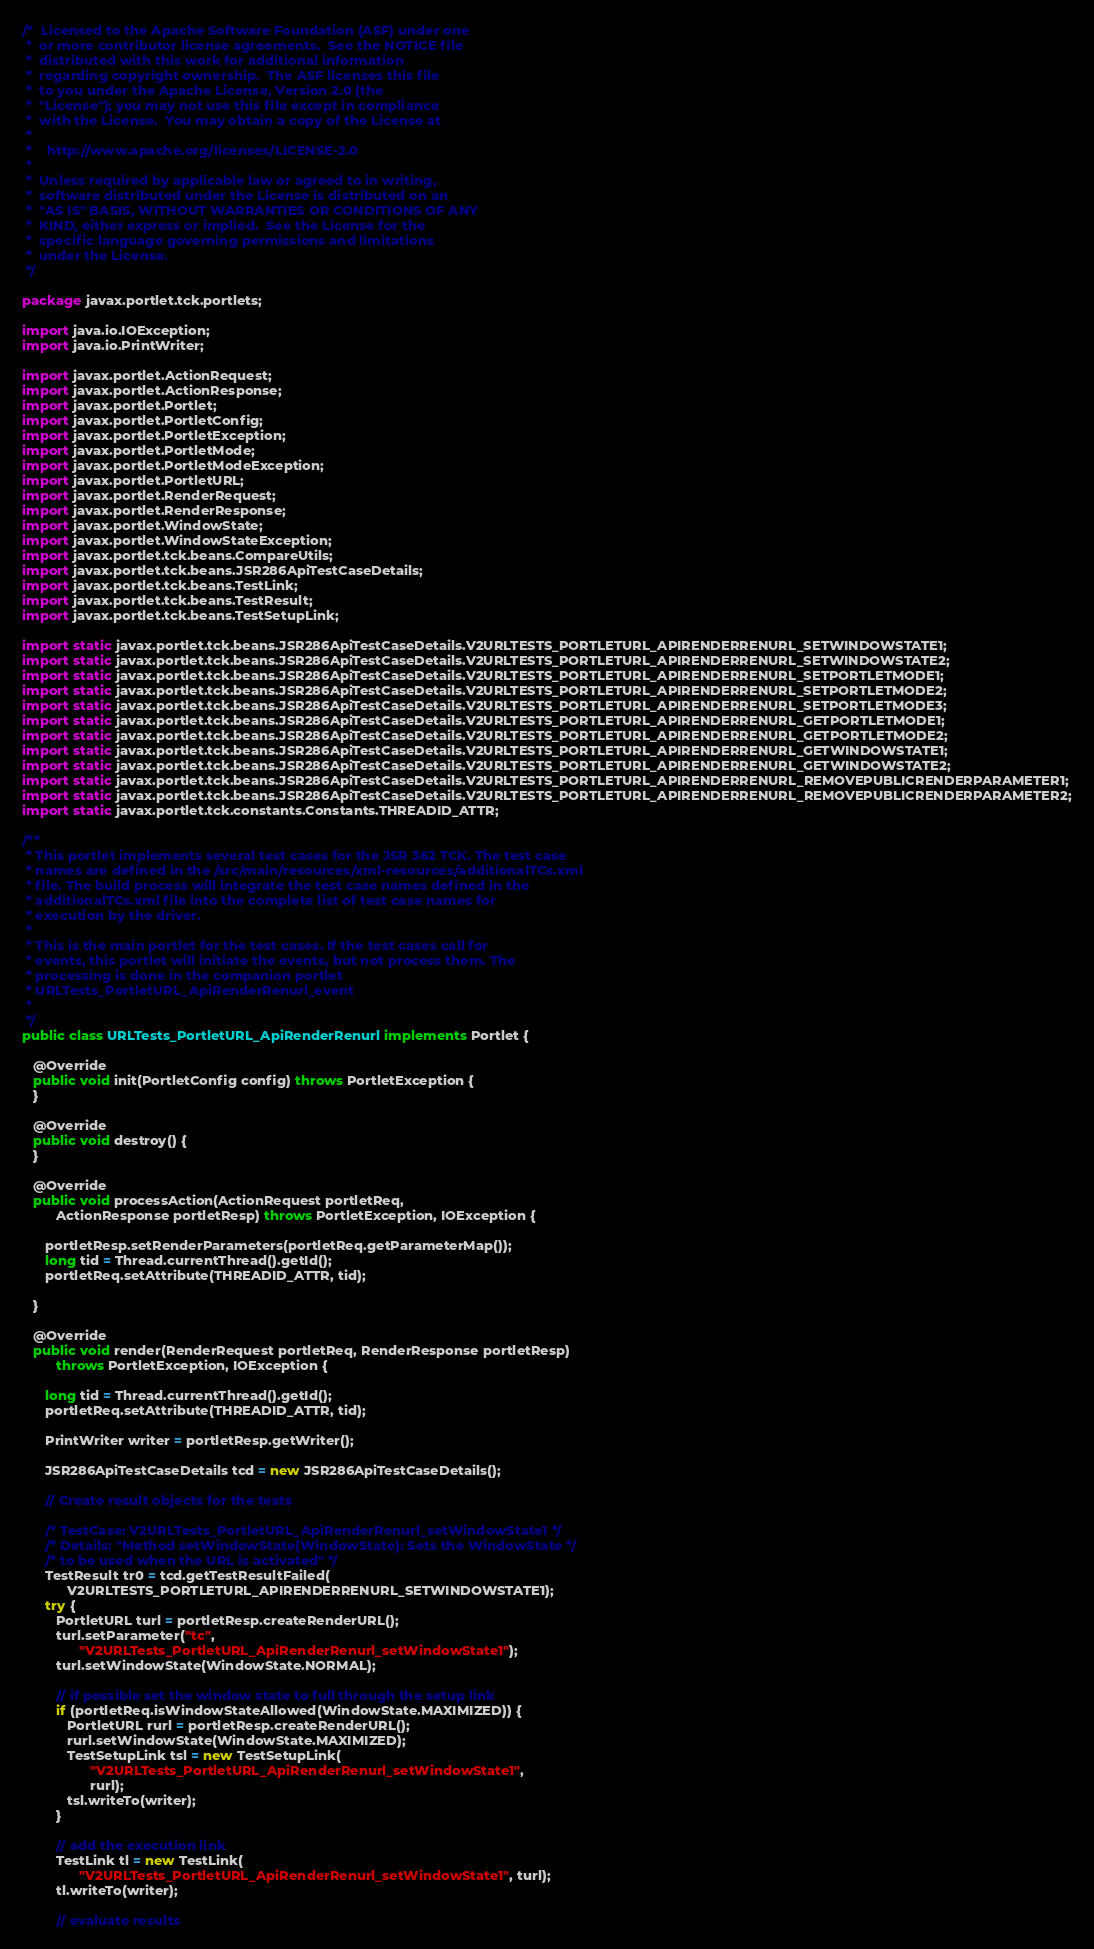Convert code to text. <code><loc_0><loc_0><loc_500><loc_500><_Java_>/*  Licensed to the Apache Software Foundation (ASF) under one
 *  or more contributor license agreements.  See the NOTICE file
 *  distributed with this work for additional information
 *  regarding copyright ownership.  The ASF licenses this file
 *  to you under the Apache License, Version 2.0 (the
 *  "License"); you may not use this file except in compliance
 *  with the License.  You may obtain a copy of the License at
 *
 *    http://www.apache.org/licenses/LICENSE-2.0
 *
 *  Unless required by applicable law or agreed to in writing,
 *  software distributed under the License is distributed on an
 *  "AS IS" BASIS, WITHOUT WARRANTIES OR CONDITIONS OF ANY
 *  KIND, either express or implied.  See the License for the
 *  specific language governing permissions and limitations
 *  under the License.
 */

package javax.portlet.tck.portlets;

import java.io.IOException;
import java.io.PrintWriter;

import javax.portlet.ActionRequest;
import javax.portlet.ActionResponse;
import javax.portlet.Portlet;
import javax.portlet.PortletConfig;
import javax.portlet.PortletException;
import javax.portlet.PortletMode;
import javax.portlet.PortletModeException;
import javax.portlet.PortletURL;
import javax.portlet.RenderRequest;
import javax.portlet.RenderResponse;
import javax.portlet.WindowState;
import javax.portlet.WindowStateException;
import javax.portlet.tck.beans.CompareUtils;
import javax.portlet.tck.beans.JSR286ApiTestCaseDetails;
import javax.portlet.tck.beans.TestLink;
import javax.portlet.tck.beans.TestResult;
import javax.portlet.tck.beans.TestSetupLink;

import static javax.portlet.tck.beans.JSR286ApiTestCaseDetails.V2URLTESTS_PORTLETURL_APIRENDERRENURL_SETWINDOWSTATE1;
import static javax.portlet.tck.beans.JSR286ApiTestCaseDetails.V2URLTESTS_PORTLETURL_APIRENDERRENURL_SETWINDOWSTATE2;
import static javax.portlet.tck.beans.JSR286ApiTestCaseDetails.V2URLTESTS_PORTLETURL_APIRENDERRENURL_SETPORTLETMODE1;
import static javax.portlet.tck.beans.JSR286ApiTestCaseDetails.V2URLTESTS_PORTLETURL_APIRENDERRENURL_SETPORTLETMODE2;
import static javax.portlet.tck.beans.JSR286ApiTestCaseDetails.V2URLTESTS_PORTLETURL_APIRENDERRENURL_SETPORTLETMODE3;
import static javax.portlet.tck.beans.JSR286ApiTestCaseDetails.V2URLTESTS_PORTLETURL_APIRENDERRENURL_GETPORTLETMODE1;
import static javax.portlet.tck.beans.JSR286ApiTestCaseDetails.V2URLTESTS_PORTLETURL_APIRENDERRENURL_GETPORTLETMODE2;
import static javax.portlet.tck.beans.JSR286ApiTestCaseDetails.V2URLTESTS_PORTLETURL_APIRENDERRENURL_GETWINDOWSTATE1;
import static javax.portlet.tck.beans.JSR286ApiTestCaseDetails.V2URLTESTS_PORTLETURL_APIRENDERRENURL_GETWINDOWSTATE2;
import static javax.portlet.tck.beans.JSR286ApiTestCaseDetails.V2URLTESTS_PORTLETURL_APIRENDERRENURL_REMOVEPUBLICRENDERPARAMETER1;
import static javax.portlet.tck.beans.JSR286ApiTestCaseDetails.V2URLTESTS_PORTLETURL_APIRENDERRENURL_REMOVEPUBLICRENDERPARAMETER2;
import static javax.portlet.tck.constants.Constants.THREADID_ATTR;

/**
 * This portlet implements several test cases for the JSR 362 TCK. The test case
 * names are defined in the /src/main/resources/xml-resources/additionalTCs.xml
 * file. The build process will integrate the test case names defined in the
 * additionalTCs.xml file into the complete list of test case names for
 * execution by the driver.
 *
 * This is the main portlet for the test cases. If the test cases call for
 * events, this portlet will initiate the events, but not process them. The
 * processing is done in the companion portlet
 * URLTests_PortletURL_ApiRenderRenurl_event
 *
 */
public class URLTests_PortletURL_ApiRenderRenurl implements Portlet {

   @Override
   public void init(PortletConfig config) throws PortletException {
   }

   @Override
   public void destroy() {
   }

   @Override
   public void processAction(ActionRequest portletReq,
         ActionResponse portletResp) throws PortletException, IOException {

      portletResp.setRenderParameters(portletReq.getParameterMap());
      long tid = Thread.currentThread().getId();
      portletReq.setAttribute(THREADID_ATTR, tid);

   }

   @Override
   public void render(RenderRequest portletReq, RenderResponse portletResp)
         throws PortletException, IOException {

      long tid = Thread.currentThread().getId();
      portletReq.setAttribute(THREADID_ATTR, tid);

      PrintWriter writer = portletResp.getWriter();

      JSR286ApiTestCaseDetails tcd = new JSR286ApiTestCaseDetails();

      // Create result objects for the tests

      /* TestCase: V2URLTests_PortletURL_ApiRenderRenurl_setWindowState1 */
      /* Details: "Method setWindowState(WindowState): Sets the WindowState */
      /* to be used when the URL is activated" */
      TestResult tr0 = tcd.getTestResultFailed(
            V2URLTESTS_PORTLETURL_APIRENDERRENURL_SETWINDOWSTATE1);
      try {
         PortletURL turl = portletResp.createRenderURL();
         turl.setParameter("tc",
               "V2URLTests_PortletURL_ApiRenderRenurl_setWindowState1");
         turl.setWindowState(WindowState.NORMAL);

         // if possible set the window state to full through the setup link
         if (portletReq.isWindowStateAllowed(WindowState.MAXIMIZED)) {
            PortletURL rurl = portletResp.createRenderURL();
            rurl.setWindowState(WindowState.MAXIMIZED);
            TestSetupLink tsl = new TestSetupLink(
                  "V2URLTests_PortletURL_ApiRenderRenurl_setWindowState1",
                  rurl);
            tsl.writeTo(writer);
         }

         // add the execution link
         TestLink tl = new TestLink(
               "V2URLTests_PortletURL_ApiRenderRenurl_setWindowState1", turl);
         tl.writeTo(writer);

         // evaluate results</code> 